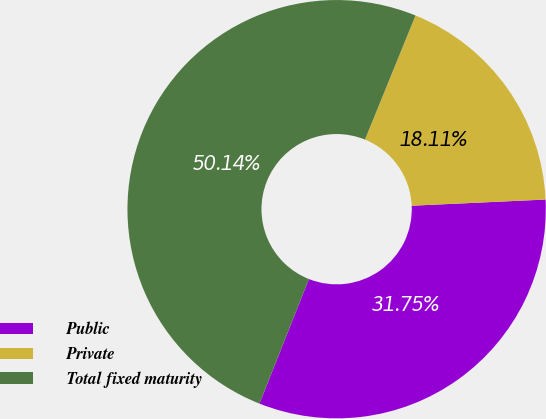Convert chart to OTSL. <chart><loc_0><loc_0><loc_500><loc_500><pie_chart><fcel>Public<fcel>Private<fcel>Total fixed maturity<nl><fcel>31.75%<fcel>18.11%<fcel>50.14%<nl></chart> 